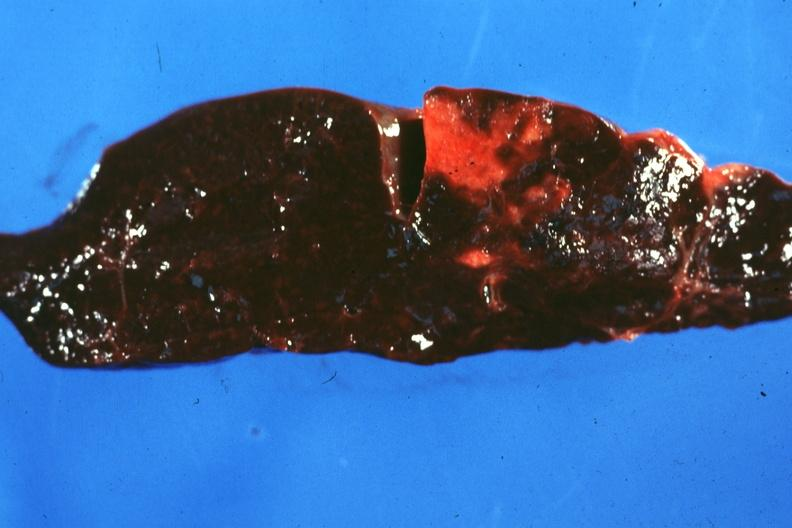s spleen present?
Answer the question using a single word or phrase. Yes 